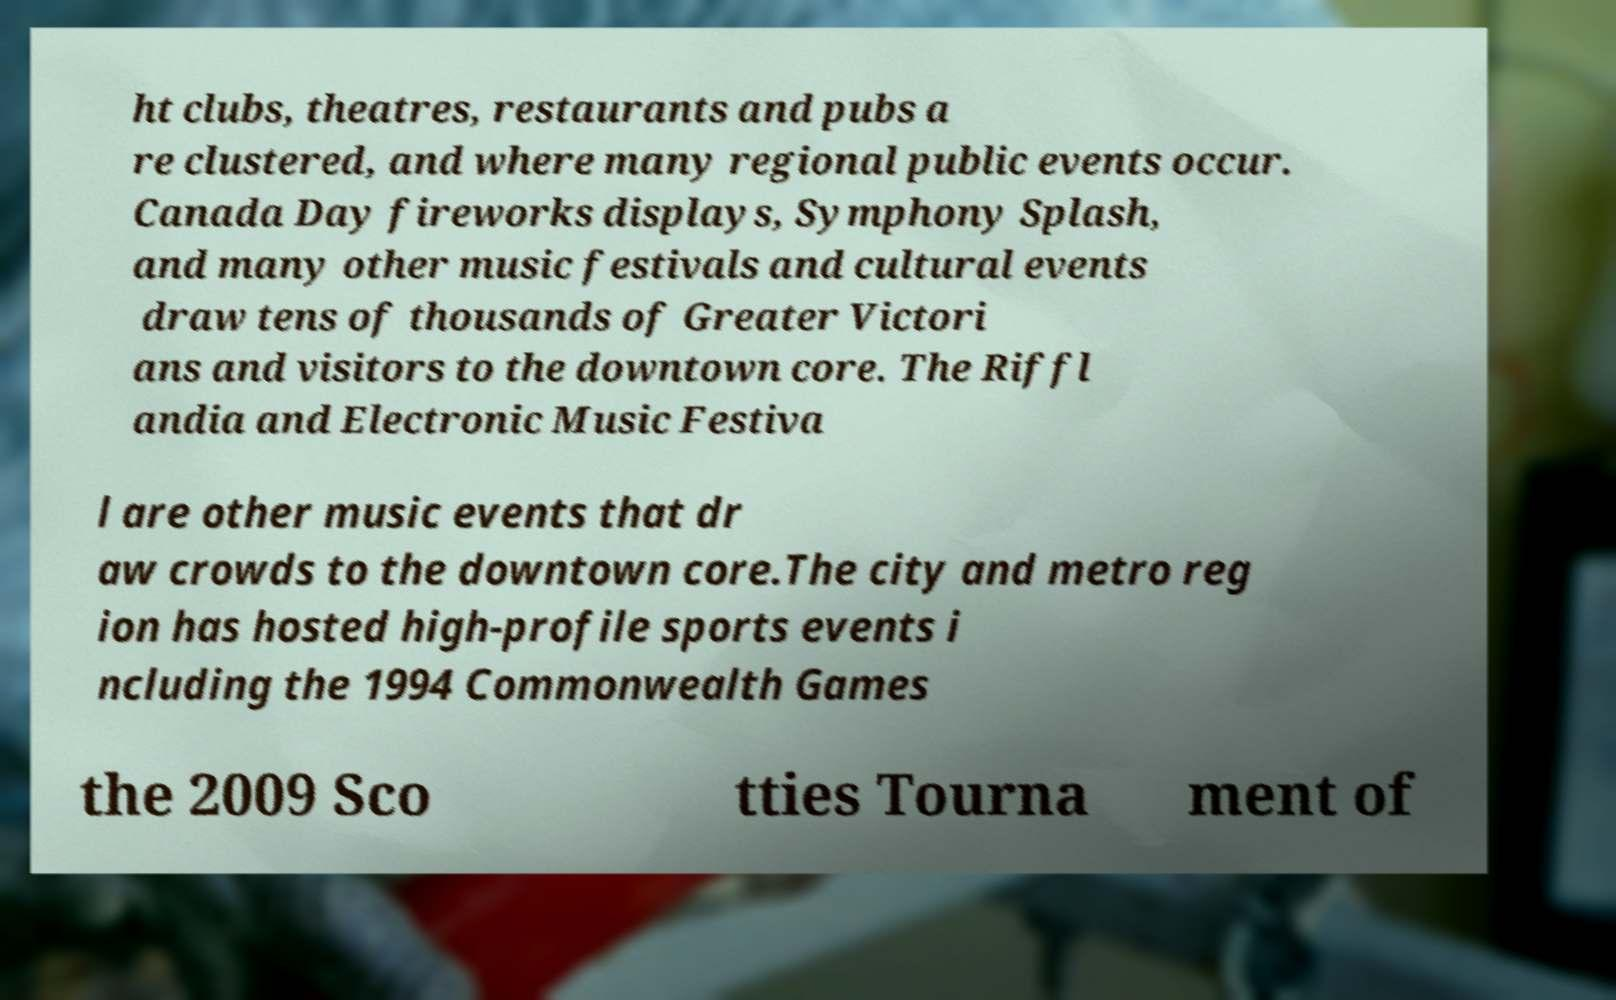Please read and relay the text visible in this image. What does it say? ht clubs, theatres, restaurants and pubs a re clustered, and where many regional public events occur. Canada Day fireworks displays, Symphony Splash, and many other music festivals and cultural events draw tens of thousands of Greater Victori ans and visitors to the downtown core. The Riffl andia and Electronic Music Festiva l are other music events that dr aw crowds to the downtown core.The city and metro reg ion has hosted high-profile sports events i ncluding the 1994 Commonwealth Games the 2009 Sco tties Tourna ment of 